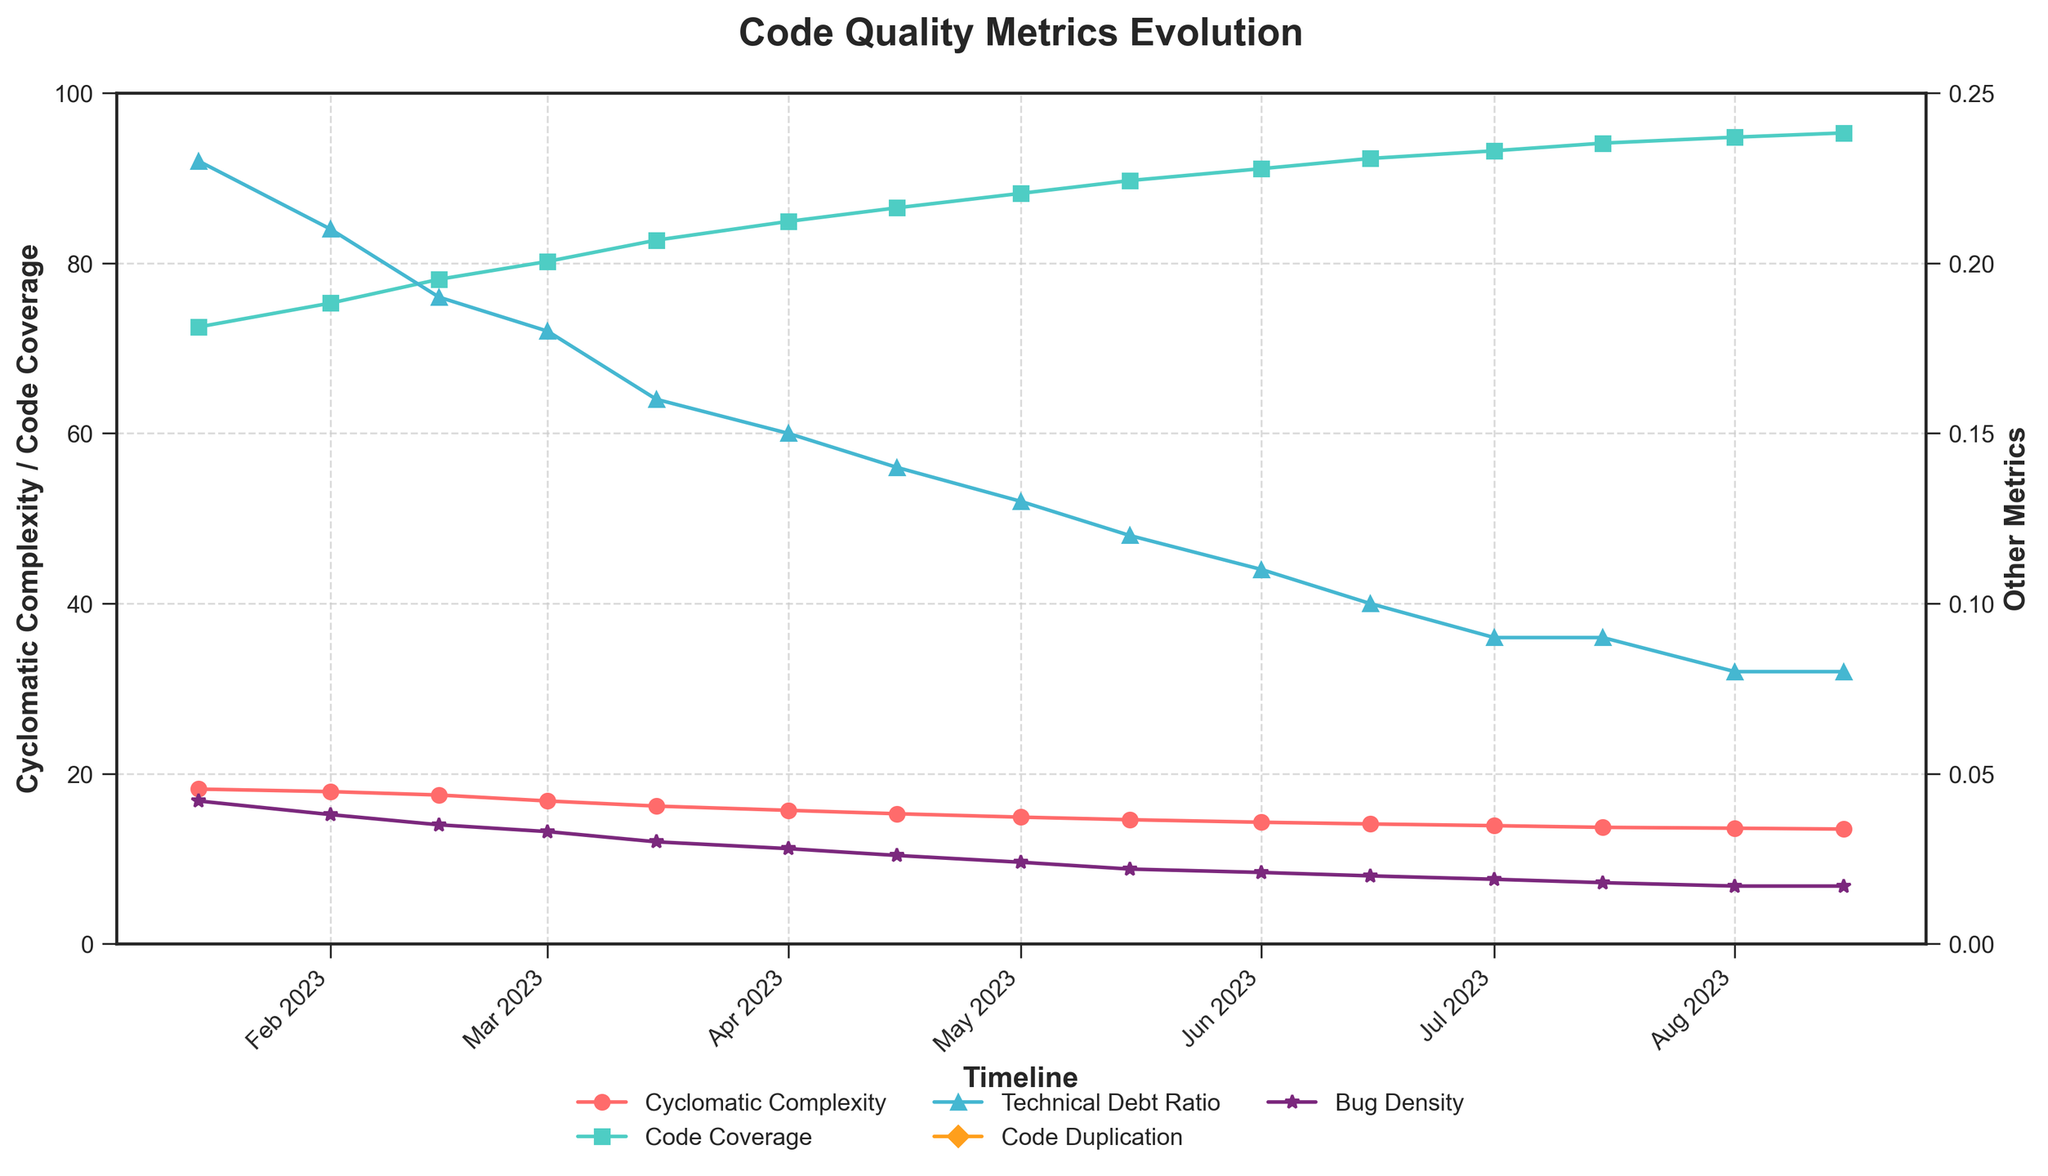What is the trend in cyclomatic complexity from January to August 2023? The cyclomatic complexity decreases consistently over time, starting from 18.2 in January and reaching 13.5 in August.
Answer: Decreasing Which metric has the most significant improvement by percentage from January to August 2023? Calculate the percentage improvement for each metric: Cyclomatic Complexity from 18.2 to 13.5 is (18.2-13.5)/18.2 = 25.82%, Code Coverage from 72.5 to 95.3 is (95.3-72.5)/72.5 = 31.59%, Technical Debt Ratio from 0.23 to 0.08 is (0.23-0.08)/0.23 = 65.22%, Code Duplication from 7.8 to 4.0 is (7.8-4.0)/7.8 = 48.72%, Bug Density from 0.042 to 0.017 is (0.042-0.017)/0.042 = 59.52%. The Technical Debt Ratio has the highest percentage improvement.
Answer: Technical Debt Ratio How does code coverage change between February and June 2023? In February, code coverage is 75.3% and in June, it is 92.3%. The change is 92.3% - 75.3% = 17%.
Answer: Increases by 17% What is the relationship between cyclomatic complexity and code coverage over the timeline? As cyclomatic complexity decreases, code coverage increases consistently throughout the timeline. They have an inverse relationship.
Answer: Inverse relationship Which month shows the highest bug density, and what is its value? The highest bug density can be found in January 2023 with a value of 0.042.
Answer: January 2023, 0.042 Compare the trend of Code Duplication and Technical Debt Ratio from March to August 2023. Both metrics decrease over time. Code Duplication decreases from 6.5 to 4.0, and Technical Debt Ratio decreases from 0.18 to 0.08.
Answer: Both decrease What is the average cyclomatic complexity over the entire period? Sum of values: 18.2+17.9+17.5+16.8+16.2+15.7+15.3+14.9+14.6+14.3+14.1+13.9+13.7+13.6+13.5 = 224.7. Number of data points is 15. The average is 224.7 / 15 ≈ 14.98.
Answer: 14.98 What can you infer about code coverage growth rate from March to August 2023 as compared to January to March 2023? From January to March, code coverage increased from 72.5% to 82.7% (10.2%). From March to August, it increased from 82.7% to 95.3% (12.6%). The growth rate is slightly higher from March to August.
Answer: Slightly higher In which period did the bug density show the most significant reduction? Compare the reductions in intervals: Initial (Jan 15 - Feb 1), it dropped from 0.042 to 0.038. The most significant reduction occurred from Jan to Feb where it dropped 0.042 - 0.038 = 0.004.
Answer: January to February 